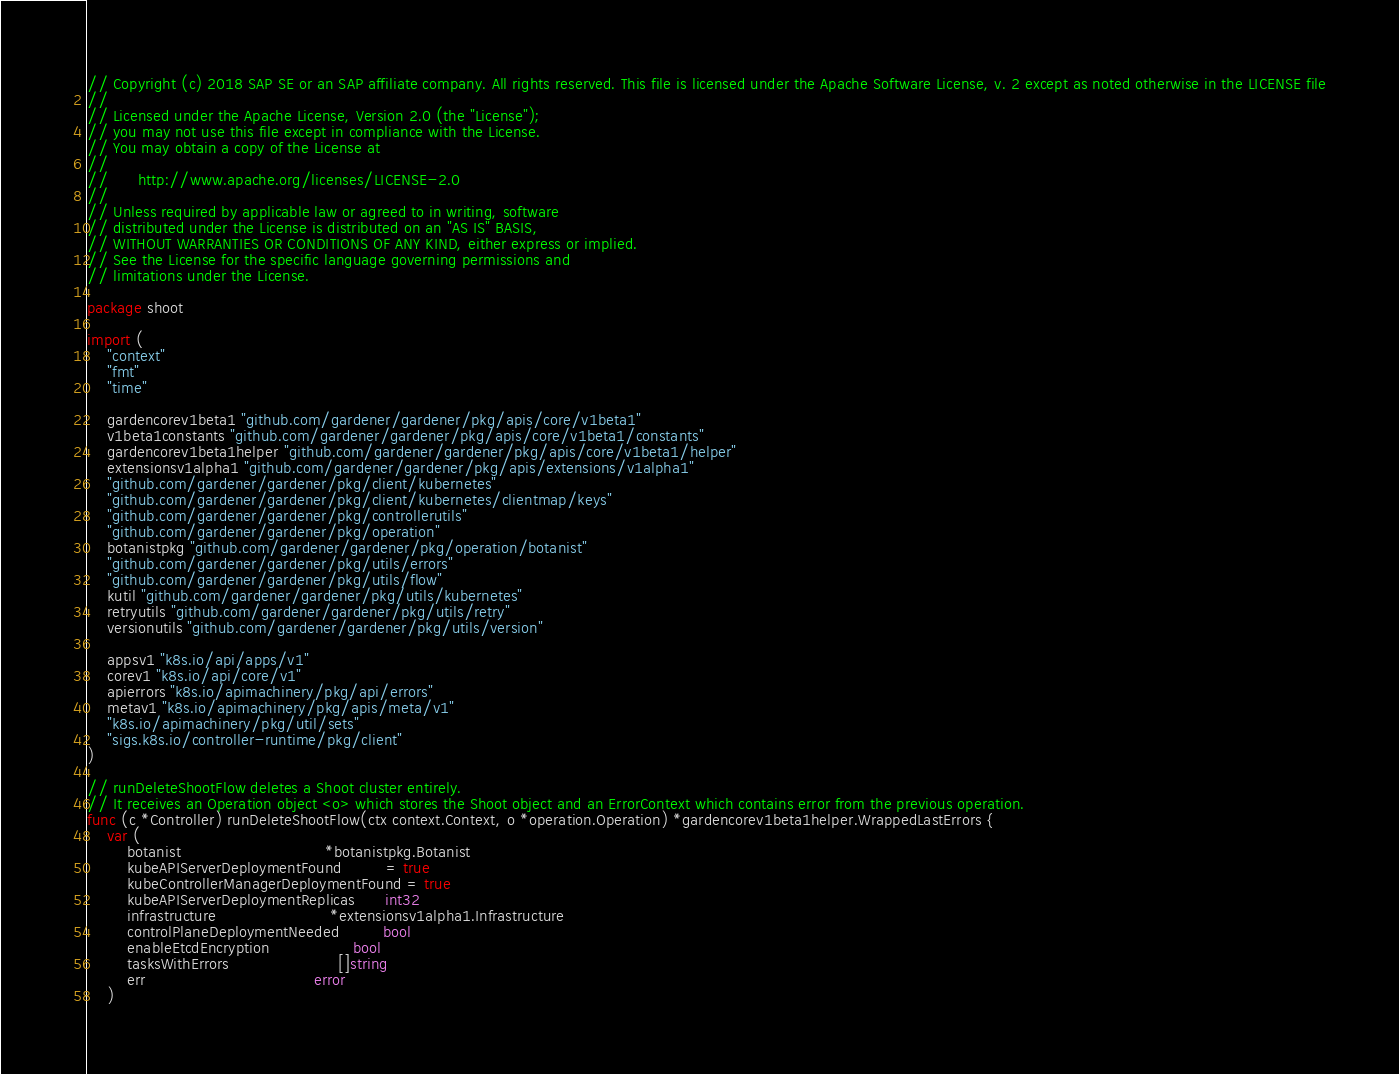<code> <loc_0><loc_0><loc_500><loc_500><_Go_>// Copyright (c) 2018 SAP SE or an SAP affiliate company. All rights reserved. This file is licensed under the Apache Software License, v. 2 except as noted otherwise in the LICENSE file
//
// Licensed under the Apache License, Version 2.0 (the "License");
// you may not use this file except in compliance with the License.
// You may obtain a copy of the License at
//
//      http://www.apache.org/licenses/LICENSE-2.0
//
// Unless required by applicable law or agreed to in writing, software
// distributed under the License is distributed on an "AS IS" BASIS,
// WITHOUT WARRANTIES OR CONDITIONS OF ANY KIND, either express or implied.
// See the License for the specific language governing permissions and
// limitations under the License.

package shoot

import (
	"context"
	"fmt"
	"time"

	gardencorev1beta1 "github.com/gardener/gardener/pkg/apis/core/v1beta1"
	v1beta1constants "github.com/gardener/gardener/pkg/apis/core/v1beta1/constants"
	gardencorev1beta1helper "github.com/gardener/gardener/pkg/apis/core/v1beta1/helper"
	extensionsv1alpha1 "github.com/gardener/gardener/pkg/apis/extensions/v1alpha1"
	"github.com/gardener/gardener/pkg/client/kubernetes"
	"github.com/gardener/gardener/pkg/client/kubernetes/clientmap/keys"
	"github.com/gardener/gardener/pkg/controllerutils"
	"github.com/gardener/gardener/pkg/operation"
	botanistpkg "github.com/gardener/gardener/pkg/operation/botanist"
	"github.com/gardener/gardener/pkg/utils/errors"
	"github.com/gardener/gardener/pkg/utils/flow"
	kutil "github.com/gardener/gardener/pkg/utils/kubernetes"
	retryutils "github.com/gardener/gardener/pkg/utils/retry"
	versionutils "github.com/gardener/gardener/pkg/utils/version"

	appsv1 "k8s.io/api/apps/v1"
	corev1 "k8s.io/api/core/v1"
	apierrors "k8s.io/apimachinery/pkg/api/errors"
	metav1 "k8s.io/apimachinery/pkg/apis/meta/v1"
	"k8s.io/apimachinery/pkg/util/sets"
	"sigs.k8s.io/controller-runtime/pkg/client"
)

// runDeleteShootFlow deletes a Shoot cluster entirely.
// It receives an Operation object <o> which stores the Shoot object and an ErrorContext which contains error from the previous operation.
func (c *Controller) runDeleteShootFlow(ctx context.Context, o *operation.Operation) *gardencorev1beta1helper.WrappedLastErrors {
	var (
		botanist                             *botanistpkg.Botanist
		kubeAPIServerDeploymentFound         = true
		kubeControllerManagerDeploymentFound = true
		kubeAPIServerDeploymentReplicas      int32
		infrastructure                       *extensionsv1alpha1.Infrastructure
		controlPlaneDeploymentNeeded         bool
		enableEtcdEncryption                 bool
		tasksWithErrors                      []string
		err                                  error
	)
</code> 